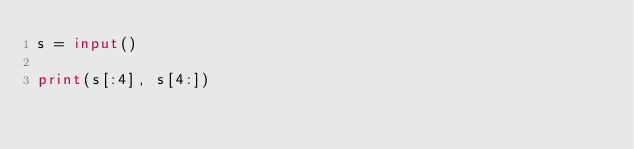Convert code to text. <code><loc_0><loc_0><loc_500><loc_500><_Python_>s = input()

print(s[:4], s[4:])
</code> 